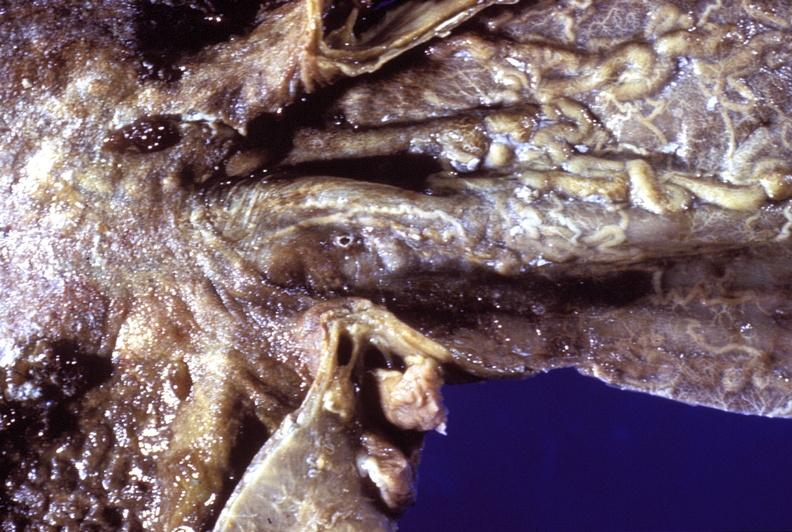does side show esophagus, esophogeal varices?
Answer the question using a single word or phrase. No 